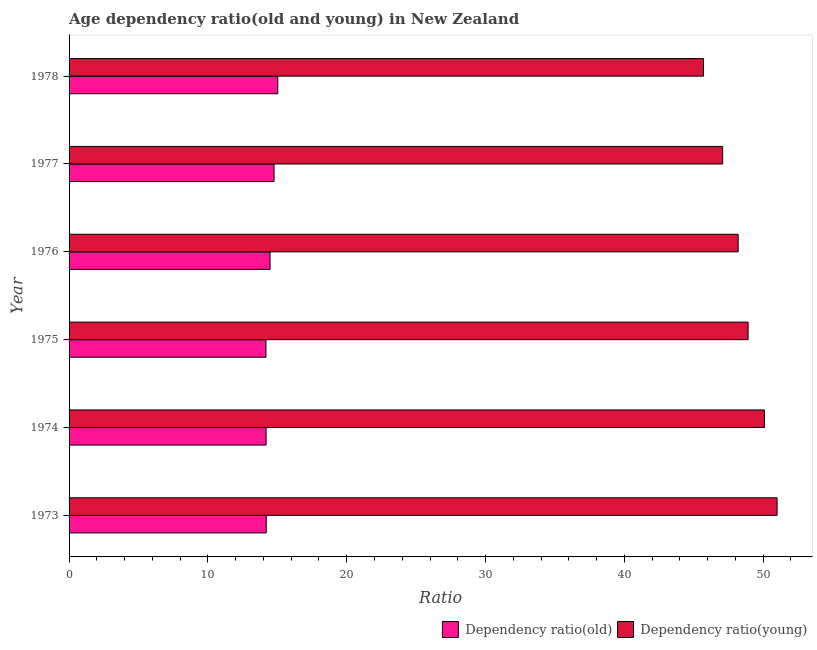How many groups of bars are there?
Give a very brief answer. 6. How many bars are there on the 5th tick from the top?
Offer a very short reply. 2. How many bars are there on the 3rd tick from the bottom?
Make the answer very short. 2. In how many cases, is the number of bars for a given year not equal to the number of legend labels?
Make the answer very short. 0. What is the age dependency ratio(old) in 1977?
Provide a short and direct response. 14.77. Across all years, what is the maximum age dependency ratio(old)?
Provide a short and direct response. 15.03. Across all years, what is the minimum age dependency ratio(young)?
Give a very brief answer. 45.7. In which year was the age dependency ratio(old) maximum?
Offer a very short reply. 1978. In which year was the age dependency ratio(young) minimum?
Make the answer very short. 1978. What is the total age dependency ratio(old) in the graph?
Offer a very short reply. 86.86. What is the difference between the age dependency ratio(young) in 1973 and that in 1975?
Provide a succinct answer. 2.09. What is the difference between the age dependency ratio(young) in 1978 and the age dependency ratio(old) in 1973?
Give a very brief answer. 31.49. What is the average age dependency ratio(old) per year?
Your answer should be very brief. 14.48. In the year 1978, what is the difference between the age dependency ratio(old) and age dependency ratio(young)?
Your answer should be very brief. -30.66. What is the ratio of the age dependency ratio(old) in 1973 to that in 1978?
Provide a succinct answer. 0.94. Is the age dependency ratio(young) in 1976 less than that in 1977?
Provide a short and direct response. No. What is the difference between the highest and the second highest age dependency ratio(old)?
Keep it short and to the point. 0.27. In how many years, is the age dependency ratio(young) greater than the average age dependency ratio(young) taken over all years?
Provide a short and direct response. 3. Is the sum of the age dependency ratio(old) in 1973 and 1978 greater than the maximum age dependency ratio(young) across all years?
Offer a terse response. No. What does the 2nd bar from the top in 1978 represents?
Provide a succinct answer. Dependency ratio(old). What does the 2nd bar from the bottom in 1973 represents?
Offer a very short reply. Dependency ratio(young). What is the difference between two consecutive major ticks on the X-axis?
Give a very brief answer. 10. Are the values on the major ticks of X-axis written in scientific E-notation?
Make the answer very short. No. Where does the legend appear in the graph?
Give a very brief answer. Bottom right. How are the legend labels stacked?
Ensure brevity in your answer.  Horizontal. What is the title of the graph?
Your response must be concise. Age dependency ratio(old and young) in New Zealand. Does "Sanitation services" appear as one of the legend labels in the graph?
Offer a terse response. No. What is the label or title of the X-axis?
Offer a terse response. Ratio. What is the label or title of the Y-axis?
Offer a terse response. Year. What is the Ratio in Dependency ratio(old) in 1973?
Provide a succinct answer. 14.2. What is the Ratio in Dependency ratio(young) in 1973?
Offer a very short reply. 51. What is the Ratio in Dependency ratio(old) in 1974?
Provide a short and direct response. 14.19. What is the Ratio in Dependency ratio(young) in 1974?
Your answer should be very brief. 50.09. What is the Ratio in Dependency ratio(old) in 1975?
Your answer should be very brief. 14.18. What is the Ratio of Dependency ratio(young) in 1975?
Keep it short and to the point. 48.91. What is the Ratio in Dependency ratio(old) in 1976?
Offer a very short reply. 14.48. What is the Ratio of Dependency ratio(young) in 1976?
Make the answer very short. 48.2. What is the Ratio of Dependency ratio(old) in 1977?
Provide a succinct answer. 14.77. What is the Ratio of Dependency ratio(young) in 1977?
Your answer should be very brief. 47.08. What is the Ratio of Dependency ratio(old) in 1978?
Provide a succinct answer. 15.03. What is the Ratio of Dependency ratio(young) in 1978?
Your response must be concise. 45.7. Across all years, what is the maximum Ratio in Dependency ratio(old)?
Your response must be concise. 15.03. Across all years, what is the maximum Ratio of Dependency ratio(young)?
Provide a short and direct response. 51. Across all years, what is the minimum Ratio of Dependency ratio(old)?
Offer a terse response. 14.18. Across all years, what is the minimum Ratio of Dependency ratio(young)?
Offer a very short reply. 45.7. What is the total Ratio in Dependency ratio(old) in the graph?
Your answer should be compact. 86.86. What is the total Ratio of Dependency ratio(young) in the graph?
Offer a terse response. 290.98. What is the difference between the Ratio in Dependency ratio(old) in 1973 and that in 1974?
Provide a short and direct response. 0.01. What is the difference between the Ratio in Dependency ratio(young) in 1973 and that in 1974?
Provide a succinct answer. 0.91. What is the difference between the Ratio of Dependency ratio(old) in 1973 and that in 1975?
Offer a terse response. 0.02. What is the difference between the Ratio in Dependency ratio(young) in 1973 and that in 1975?
Make the answer very short. 2.09. What is the difference between the Ratio of Dependency ratio(old) in 1973 and that in 1976?
Offer a terse response. -0.27. What is the difference between the Ratio of Dependency ratio(young) in 1973 and that in 1976?
Give a very brief answer. 2.81. What is the difference between the Ratio of Dependency ratio(old) in 1973 and that in 1977?
Give a very brief answer. -0.56. What is the difference between the Ratio of Dependency ratio(young) in 1973 and that in 1977?
Provide a succinct answer. 3.92. What is the difference between the Ratio of Dependency ratio(old) in 1973 and that in 1978?
Make the answer very short. -0.83. What is the difference between the Ratio in Dependency ratio(young) in 1973 and that in 1978?
Your answer should be compact. 5.3. What is the difference between the Ratio in Dependency ratio(old) in 1974 and that in 1975?
Make the answer very short. 0.01. What is the difference between the Ratio of Dependency ratio(young) in 1974 and that in 1975?
Ensure brevity in your answer.  1.18. What is the difference between the Ratio in Dependency ratio(old) in 1974 and that in 1976?
Make the answer very short. -0.29. What is the difference between the Ratio in Dependency ratio(young) in 1974 and that in 1976?
Your answer should be compact. 1.89. What is the difference between the Ratio of Dependency ratio(old) in 1974 and that in 1977?
Your response must be concise. -0.57. What is the difference between the Ratio in Dependency ratio(young) in 1974 and that in 1977?
Offer a terse response. 3.01. What is the difference between the Ratio in Dependency ratio(old) in 1974 and that in 1978?
Your answer should be very brief. -0.84. What is the difference between the Ratio in Dependency ratio(young) in 1974 and that in 1978?
Your response must be concise. 4.39. What is the difference between the Ratio in Dependency ratio(old) in 1975 and that in 1976?
Give a very brief answer. -0.29. What is the difference between the Ratio in Dependency ratio(young) in 1975 and that in 1976?
Your answer should be very brief. 0.72. What is the difference between the Ratio in Dependency ratio(old) in 1975 and that in 1977?
Your answer should be compact. -0.58. What is the difference between the Ratio in Dependency ratio(young) in 1975 and that in 1977?
Offer a very short reply. 1.83. What is the difference between the Ratio in Dependency ratio(old) in 1975 and that in 1978?
Give a very brief answer. -0.85. What is the difference between the Ratio of Dependency ratio(young) in 1975 and that in 1978?
Your answer should be compact. 3.22. What is the difference between the Ratio in Dependency ratio(old) in 1976 and that in 1977?
Provide a succinct answer. -0.29. What is the difference between the Ratio of Dependency ratio(young) in 1976 and that in 1977?
Provide a succinct answer. 1.11. What is the difference between the Ratio of Dependency ratio(old) in 1976 and that in 1978?
Your answer should be compact. -0.56. What is the difference between the Ratio of Dependency ratio(young) in 1976 and that in 1978?
Provide a short and direct response. 2.5. What is the difference between the Ratio in Dependency ratio(old) in 1977 and that in 1978?
Your answer should be compact. -0.27. What is the difference between the Ratio of Dependency ratio(young) in 1977 and that in 1978?
Your response must be concise. 1.38. What is the difference between the Ratio of Dependency ratio(old) in 1973 and the Ratio of Dependency ratio(young) in 1974?
Keep it short and to the point. -35.89. What is the difference between the Ratio in Dependency ratio(old) in 1973 and the Ratio in Dependency ratio(young) in 1975?
Give a very brief answer. -34.71. What is the difference between the Ratio in Dependency ratio(old) in 1973 and the Ratio in Dependency ratio(young) in 1976?
Make the answer very short. -33.99. What is the difference between the Ratio of Dependency ratio(old) in 1973 and the Ratio of Dependency ratio(young) in 1977?
Make the answer very short. -32.88. What is the difference between the Ratio in Dependency ratio(old) in 1973 and the Ratio in Dependency ratio(young) in 1978?
Your answer should be very brief. -31.49. What is the difference between the Ratio of Dependency ratio(old) in 1974 and the Ratio of Dependency ratio(young) in 1975?
Your response must be concise. -34.72. What is the difference between the Ratio in Dependency ratio(old) in 1974 and the Ratio in Dependency ratio(young) in 1976?
Offer a very short reply. -34. What is the difference between the Ratio in Dependency ratio(old) in 1974 and the Ratio in Dependency ratio(young) in 1977?
Your response must be concise. -32.89. What is the difference between the Ratio of Dependency ratio(old) in 1974 and the Ratio of Dependency ratio(young) in 1978?
Offer a very short reply. -31.51. What is the difference between the Ratio in Dependency ratio(old) in 1975 and the Ratio in Dependency ratio(young) in 1976?
Offer a terse response. -34.01. What is the difference between the Ratio in Dependency ratio(old) in 1975 and the Ratio in Dependency ratio(young) in 1977?
Provide a succinct answer. -32.9. What is the difference between the Ratio in Dependency ratio(old) in 1975 and the Ratio in Dependency ratio(young) in 1978?
Give a very brief answer. -31.51. What is the difference between the Ratio of Dependency ratio(old) in 1976 and the Ratio of Dependency ratio(young) in 1977?
Give a very brief answer. -32.6. What is the difference between the Ratio of Dependency ratio(old) in 1976 and the Ratio of Dependency ratio(young) in 1978?
Provide a short and direct response. -31.22. What is the difference between the Ratio of Dependency ratio(old) in 1977 and the Ratio of Dependency ratio(young) in 1978?
Keep it short and to the point. -30.93. What is the average Ratio in Dependency ratio(old) per year?
Provide a succinct answer. 14.48. What is the average Ratio of Dependency ratio(young) per year?
Give a very brief answer. 48.5. In the year 1973, what is the difference between the Ratio of Dependency ratio(old) and Ratio of Dependency ratio(young)?
Keep it short and to the point. -36.8. In the year 1974, what is the difference between the Ratio in Dependency ratio(old) and Ratio in Dependency ratio(young)?
Offer a terse response. -35.9. In the year 1975, what is the difference between the Ratio of Dependency ratio(old) and Ratio of Dependency ratio(young)?
Your answer should be very brief. -34.73. In the year 1976, what is the difference between the Ratio in Dependency ratio(old) and Ratio in Dependency ratio(young)?
Offer a terse response. -33.72. In the year 1977, what is the difference between the Ratio in Dependency ratio(old) and Ratio in Dependency ratio(young)?
Make the answer very short. -32.32. In the year 1978, what is the difference between the Ratio of Dependency ratio(old) and Ratio of Dependency ratio(young)?
Provide a short and direct response. -30.66. What is the ratio of the Ratio in Dependency ratio(old) in 1973 to that in 1974?
Your answer should be compact. 1. What is the ratio of the Ratio in Dependency ratio(young) in 1973 to that in 1974?
Your response must be concise. 1.02. What is the ratio of the Ratio in Dependency ratio(young) in 1973 to that in 1975?
Provide a succinct answer. 1.04. What is the ratio of the Ratio in Dependency ratio(old) in 1973 to that in 1976?
Keep it short and to the point. 0.98. What is the ratio of the Ratio of Dependency ratio(young) in 1973 to that in 1976?
Provide a succinct answer. 1.06. What is the ratio of the Ratio of Dependency ratio(old) in 1973 to that in 1977?
Offer a terse response. 0.96. What is the ratio of the Ratio of Dependency ratio(old) in 1973 to that in 1978?
Offer a very short reply. 0.94. What is the ratio of the Ratio of Dependency ratio(young) in 1973 to that in 1978?
Keep it short and to the point. 1.12. What is the ratio of the Ratio in Dependency ratio(old) in 1974 to that in 1975?
Make the answer very short. 1. What is the ratio of the Ratio of Dependency ratio(young) in 1974 to that in 1975?
Make the answer very short. 1.02. What is the ratio of the Ratio of Dependency ratio(old) in 1974 to that in 1976?
Ensure brevity in your answer.  0.98. What is the ratio of the Ratio in Dependency ratio(young) in 1974 to that in 1976?
Offer a terse response. 1.04. What is the ratio of the Ratio in Dependency ratio(old) in 1974 to that in 1977?
Provide a short and direct response. 0.96. What is the ratio of the Ratio in Dependency ratio(young) in 1974 to that in 1977?
Keep it short and to the point. 1.06. What is the ratio of the Ratio of Dependency ratio(old) in 1974 to that in 1978?
Offer a terse response. 0.94. What is the ratio of the Ratio of Dependency ratio(young) in 1974 to that in 1978?
Offer a very short reply. 1.1. What is the ratio of the Ratio in Dependency ratio(old) in 1975 to that in 1976?
Keep it short and to the point. 0.98. What is the ratio of the Ratio in Dependency ratio(young) in 1975 to that in 1976?
Your answer should be compact. 1.01. What is the ratio of the Ratio of Dependency ratio(old) in 1975 to that in 1977?
Keep it short and to the point. 0.96. What is the ratio of the Ratio in Dependency ratio(young) in 1975 to that in 1977?
Your answer should be compact. 1.04. What is the ratio of the Ratio of Dependency ratio(old) in 1975 to that in 1978?
Offer a very short reply. 0.94. What is the ratio of the Ratio in Dependency ratio(young) in 1975 to that in 1978?
Give a very brief answer. 1.07. What is the ratio of the Ratio in Dependency ratio(old) in 1976 to that in 1977?
Your answer should be compact. 0.98. What is the ratio of the Ratio in Dependency ratio(young) in 1976 to that in 1977?
Give a very brief answer. 1.02. What is the ratio of the Ratio of Dependency ratio(old) in 1976 to that in 1978?
Keep it short and to the point. 0.96. What is the ratio of the Ratio in Dependency ratio(young) in 1976 to that in 1978?
Make the answer very short. 1.05. What is the ratio of the Ratio in Dependency ratio(old) in 1977 to that in 1978?
Offer a very short reply. 0.98. What is the ratio of the Ratio in Dependency ratio(young) in 1977 to that in 1978?
Offer a terse response. 1.03. What is the difference between the highest and the second highest Ratio in Dependency ratio(old)?
Your answer should be very brief. 0.27. What is the difference between the highest and the second highest Ratio in Dependency ratio(young)?
Give a very brief answer. 0.91. What is the difference between the highest and the lowest Ratio of Dependency ratio(old)?
Provide a short and direct response. 0.85. What is the difference between the highest and the lowest Ratio in Dependency ratio(young)?
Provide a succinct answer. 5.3. 